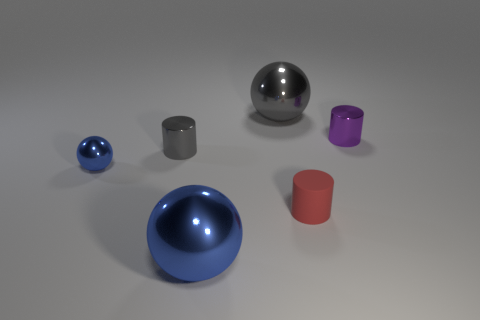Add 4 big blue spheres. How many objects exist? 10 Add 1 small red matte objects. How many small red matte objects are left? 2 Add 2 tiny blue spheres. How many tiny blue spheres exist? 3 Subtract 0 cyan blocks. How many objects are left? 6 Subtract all small gray cylinders. Subtract all small blue spheres. How many objects are left? 4 